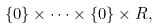Convert formula to latex. <formula><loc_0><loc_0><loc_500><loc_500>\{ 0 \} \times \cdots \times \{ 0 \} \times { R } ,</formula> 